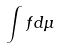Convert formula to latex. <formula><loc_0><loc_0><loc_500><loc_500>\int f d \mu</formula> 